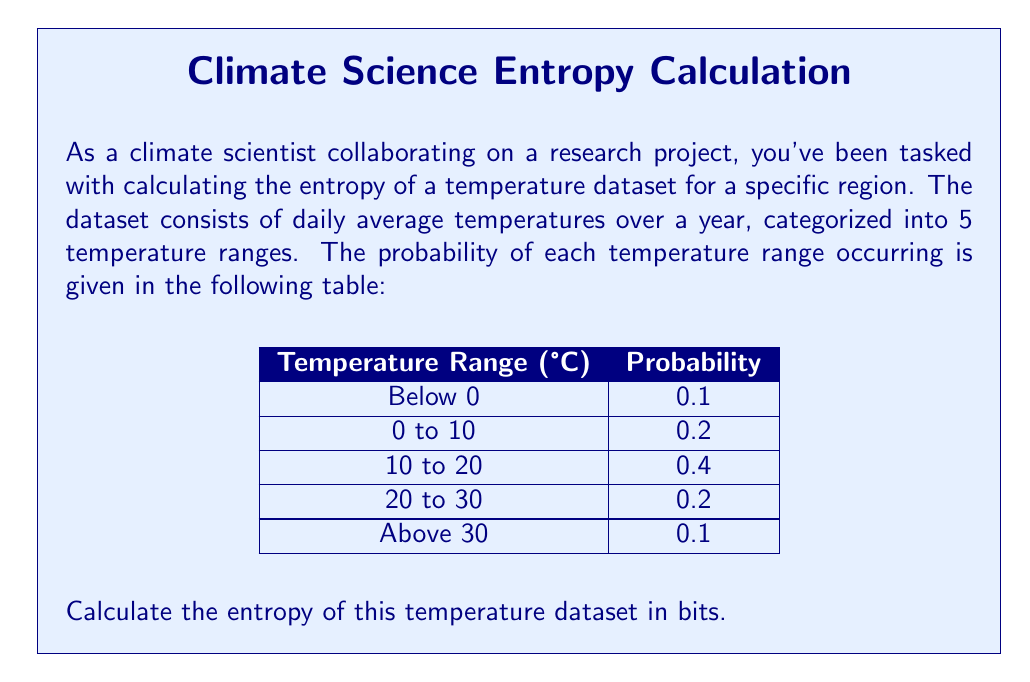Help me with this question. To calculate the entropy of the temperature dataset, we'll use the Shannon entropy formula:

$$H = -\sum_{i=1}^n p_i \log_2(p_i)$$

Where:
- $H$ is the entropy in bits
- $p_i$ is the probability of each temperature range
- $n$ is the number of temperature ranges (in this case, 5)

Let's calculate the entropy step by step:

1) For each temperature range, calculate $p_i \log_2(p_i)$:

   Below 0°C: $0.1 \log_2(0.1) = 0.1 \times (-3.32) = -0.332$
   0 to 10°C: $0.2 \log_2(0.2) = 0.2 \times (-2.32) = -0.464$
   10 to 20°C: $0.4 \log_2(0.4) = 0.4 \times (-1.32) = -0.528$
   20 to 30°C: $0.2 \log_2(0.2) = 0.2 \times (-2.32) = -0.464$
   Above 30°C: $0.1 \log_2(0.1) = 0.1 \times (-3.32) = -0.332$

2) Sum up all these values and multiply by -1:

   $H = -(-0.332 - 0.464 - 0.528 - 0.464 - 0.332)$
   
   $H = -(- 2.12)$
   
   $H = 2.12$ bits

Therefore, the entropy of the temperature dataset is 2.12 bits.
Answer: 2.12 bits 